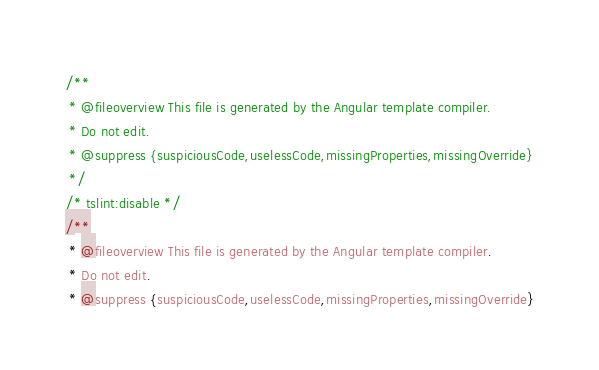<code> <loc_0><loc_0><loc_500><loc_500><_JavaScript_>/**
 * @fileoverview This file is generated by the Angular template compiler.
 * Do not edit.
 * @suppress {suspiciousCode,uselessCode,missingProperties,missingOverride}
 */
/* tslint:disable */
/**
 * @fileoverview This file is generated by the Angular template compiler.
 * Do not edit.
 * @suppress {suspiciousCode,uselessCode,missingProperties,missingOverride}</code> 